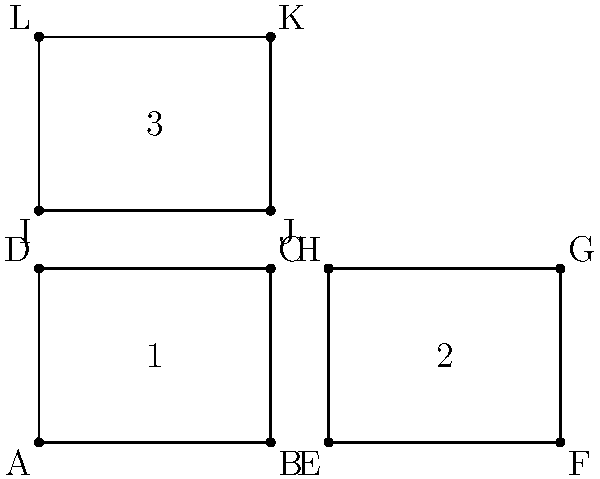In the diagram above, which represents a layout for dog kennels in your rescue organization, identify all pairs of congruent shapes. How many such pairs are there? To determine the number of pairs of congruent shapes, we need to analyze the given diagram step by step:

1. First, let's identify the shapes in the diagram:
   - Shape 1: Rectangle ABCD
   - Shape 2: Rectangle EFGH
   - Shape 3: Rectangle IJKL

2. Two shapes are congruent if they have the same size and shape. In rectangles, this means they must have the same length and width.

3. Let's compare the shapes:
   - Shape 1 (ABCD) and Shape 2 (EFGH):
     Both have a width of 4 units and a height of 3 units.
     Therefore, ABCD ≅ EFGH (congruent)

   - Shape 1 (ABCD) and Shape 3 (IJKL):
     ABCD has dimensions 4x3, while IJKL has dimensions 4x3.
     Therefore, ABCD ≅ IJKL (congruent)

   - Shape 2 (EFGH) and Shape 3 (IJKL):
     As both are congruent to Shape 1, they are also congruent to each other.
     Therefore, EFGH ≅ IJKL (congruent)

4. Counting the pairs of congruent shapes:
   - Pair 1: ABCD and EFGH
   - Pair 2: ABCD and IJKL
   - Pair 3: EFGH and IJKL

Therefore, there are 3 pairs of congruent shapes in the given kennel layout.
Answer: 3 pairs 